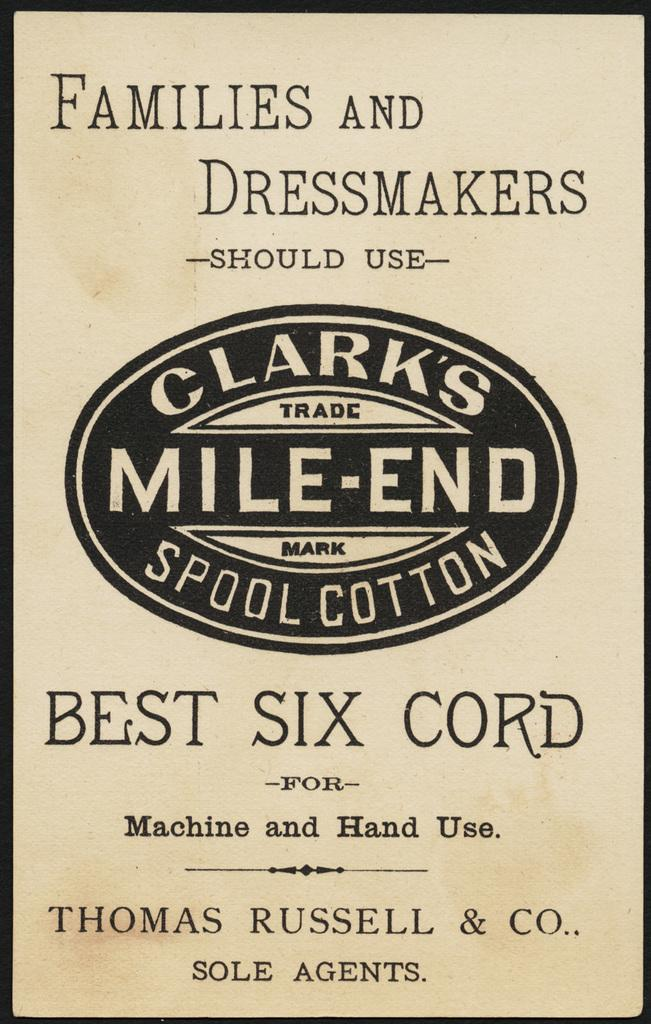Provide a one-sentence caption for the provided image. A tan box of stating the brand Clark's Mile-End Spool Cotton. 